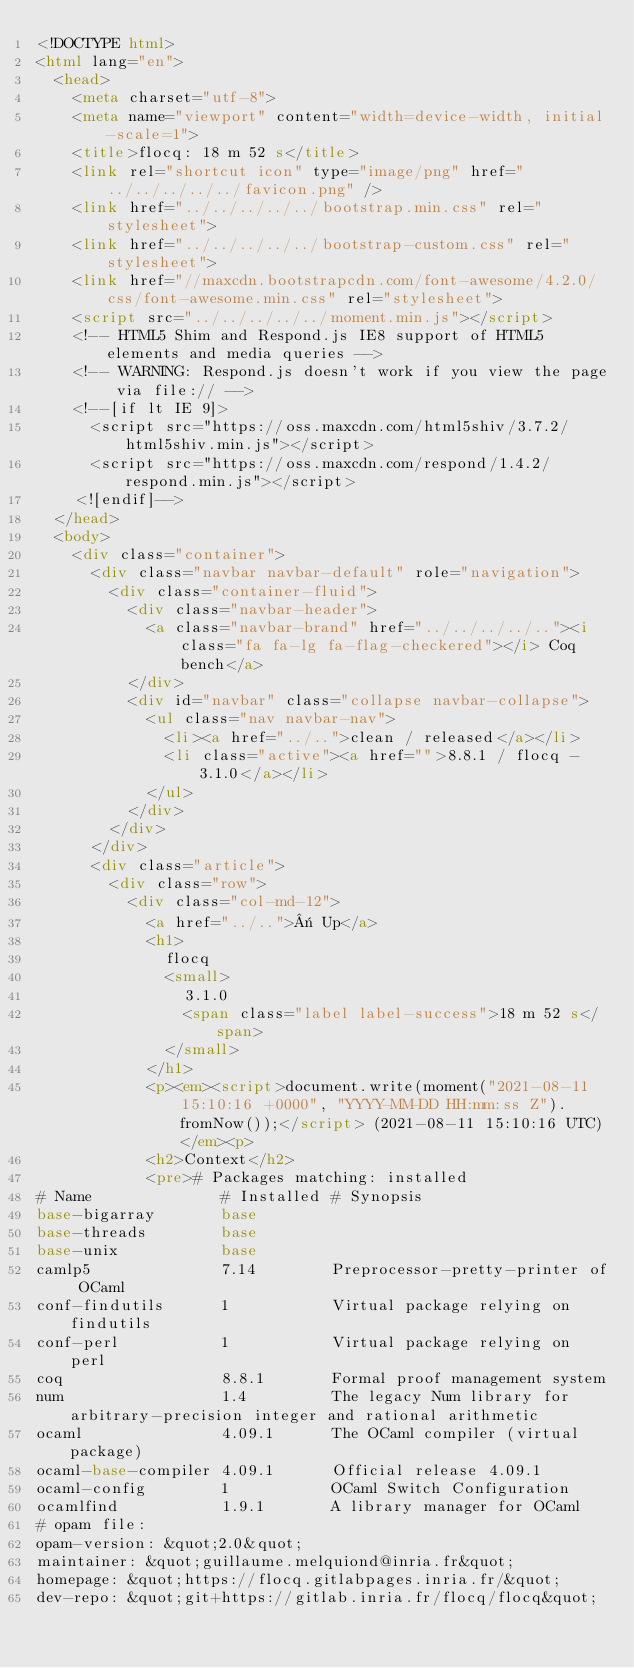Convert code to text. <code><loc_0><loc_0><loc_500><loc_500><_HTML_><!DOCTYPE html>
<html lang="en">
  <head>
    <meta charset="utf-8">
    <meta name="viewport" content="width=device-width, initial-scale=1">
    <title>flocq: 18 m 52 s</title>
    <link rel="shortcut icon" type="image/png" href="../../../../../favicon.png" />
    <link href="../../../../../bootstrap.min.css" rel="stylesheet">
    <link href="../../../../../bootstrap-custom.css" rel="stylesheet">
    <link href="//maxcdn.bootstrapcdn.com/font-awesome/4.2.0/css/font-awesome.min.css" rel="stylesheet">
    <script src="../../../../../moment.min.js"></script>
    <!-- HTML5 Shim and Respond.js IE8 support of HTML5 elements and media queries -->
    <!-- WARNING: Respond.js doesn't work if you view the page via file:// -->
    <!--[if lt IE 9]>
      <script src="https://oss.maxcdn.com/html5shiv/3.7.2/html5shiv.min.js"></script>
      <script src="https://oss.maxcdn.com/respond/1.4.2/respond.min.js"></script>
    <![endif]-->
  </head>
  <body>
    <div class="container">
      <div class="navbar navbar-default" role="navigation">
        <div class="container-fluid">
          <div class="navbar-header">
            <a class="navbar-brand" href="../../../../.."><i class="fa fa-lg fa-flag-checkered"></i> Coq bench</a>
          </div>
          <div id="navbar" class="collapse navbar-collapse">
            <ul class="nav navbar-nav">
              <li><a href="../..">clean / released</a></li>
              <li class="active"><a href="">8.8.1 / flocq - 3.1.0</a></li>
            </ul>
          </div>
        </div>
      </div>
      <div class="article">
        <div class="row">
          <div class="col-md-12">
            <a href="../..">« Up</a>
            <h1>
              flocq
              <small>
                3.1.0
                <span class="label label-success">18 m 52 s</span>
              </small>
            </h1>
            <p><em><script>document.write(moment("2021-08-11 15:10:16 +0000", "YYYY-MM-DD HH:mm:ss Z").fromNow());</script> (2021-08-11 15:10:16 UTC)</em><p>
            <h2>Context</h2>
            <pre># Packages matching: installed
# Name              # Installed # Synopsis
base-bigarray       base
base-threads        base
base-unix           base
camlp5              7.14        Preprocessor-pretty-printer of OCaml
conf-findutils      1           Virtual package relying on findutils
conf-perl           1           Virtual package relying on perl
coq                 8.8.1       Formal proof management system
num                 1.4         The legacy Num library for arbitrary-precision integer and rational arithmetic
ocaml               4.09.1      The OCaml compiler (virtual package)
ocaml-base-compiler 4.09.1      Official release 4.09.1
ocaml-config        1           OCaml Switch Configuration
ocamlfind           1.9.1       A library manager for OCaml
# opam file:
opam-version: &quot;2.0&quot;
maintainer: &quot;guillaume.melquiond@inria.fr&quot;
homepage: &quot;https://flocq.gitlabpages.inria.fr/&quot;
dev-repo: &quot;git+https://gitlab.inria.fr/flocq/flocq&quot;</code> 